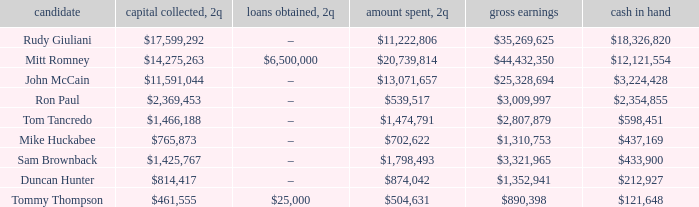Name the money spent for 2Q having candidate of john mccain $13,071,657. Could you help me parse every detail presented in this table? {'header': ['candidate', 'capital collected, 2q', 'loans obtained, 2q', 'amount spent, 2q', 'gross earnings', 'cash in hand'], 'rows': [['Rudy Giuliani', '$17,599,292', '–', '$11,222,806', '$35,269,625', '$18,326,820'], ['Mitt Romney', '$14,275,263', '$6,500,000', '$20,739,814', '$44,432,350', '$12,121,554'], ['John McCain', '$11,591,044', '–', '$13,071,657', '$25,328,694', '$3,224,428'], ['Ron Paul', '$2,369,453', '–', '$539,517', '$3,009,997', '$2,354,855'], ['Tom Tancredo', '$1,466,188', '–', '$1,474,791', '$2,807,879', '$598,451'], ['Mike Huckabee', '$765,873', '–', '$702,622', '$1,310,753', '$437,169'], ['Sam Brownback', '$1,425,767', '–', '$1,798,493', '$3,321,965', '$433,900'], ['Duncan Hunter', '$814,417', '–', '$874,042', '$1,352,941', '$212,927'], ['Tommy Thompson', '$461,555', '$25,000', '$504,631', '$890,398', '$121,648']]} 